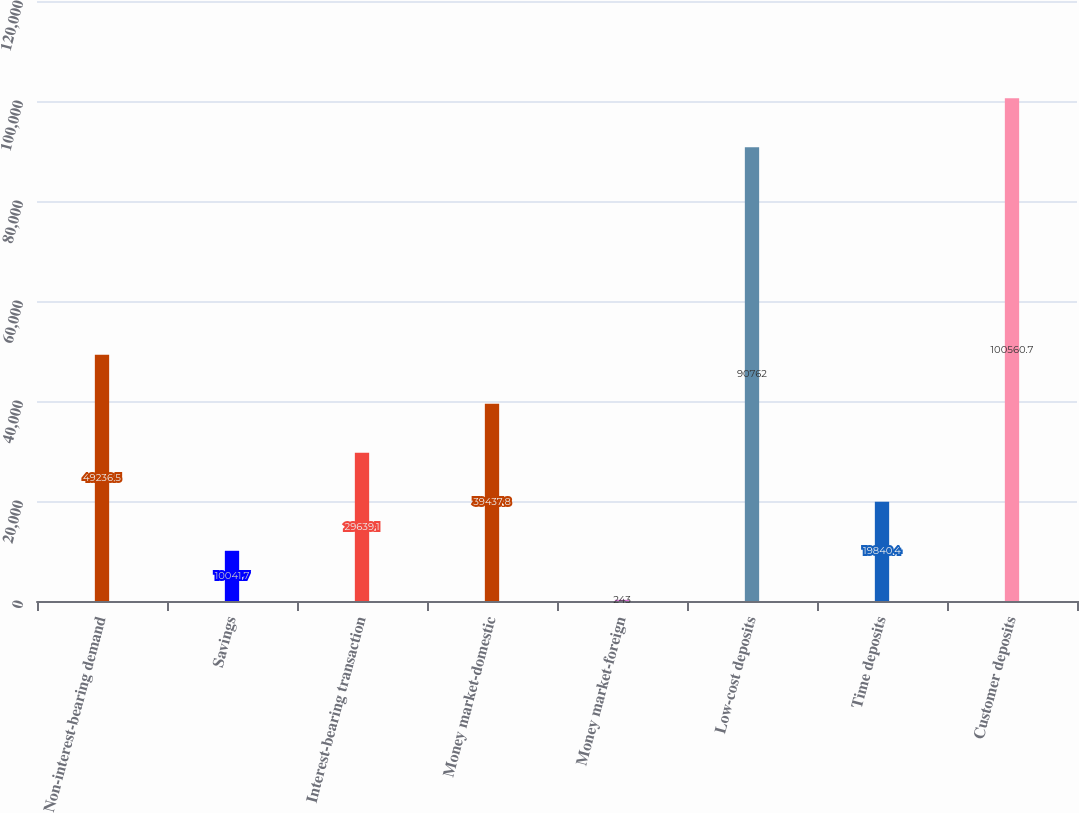Convert chart. <chart><loc_0><loc_0><loc_500><loc_500><bar_chart><fcel>Non-interest-bearing demand<fcel>Savings<fcel>Interest-bearing transaction<fcel>Money market-domestic<fcel>Money market-foreign<fcel>Low-cost deposits<fcel>Time deposits<fcel>Customer deposits<nl><fcel>49236.5<fcel>10041.7<fcel>29639.1<fcel>39437.8<fcel>243<fcel>90762<fcel>19840.4<fcel>100561<nl></chart> 